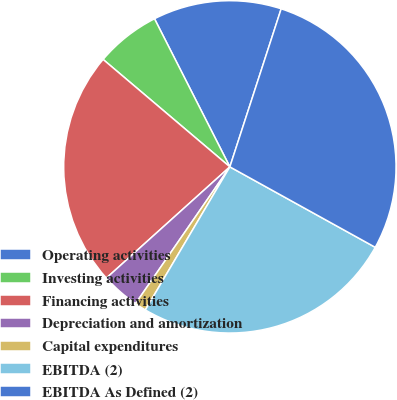Convert chart. <chart><loc_0><loc_0><loc_500><loc_500><pie_chart><fcel>Operating activities<fcel>Investing activities<fcel>Financing activities<fcel>Depreciation and amortization<fcel>Capital expenditures<fcel>EBITDA (2)<fcel>EBITDA As Defined (2)<nl><fcel>12.49%<fcel>6.32%<fcel>22.86%<fcel>3.72%<fcel>1.12%<fcel>25.45%<fcel>28.05%<nl></chart> 